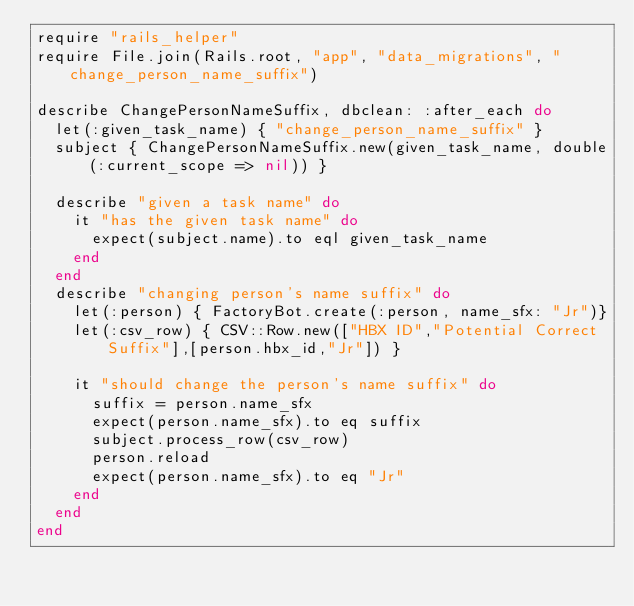<code> <loc_0><loc_0><loc_500><loc_500><_Ruby_>require "rails_helper"
require File.join(Rails.root, "app", "data_migrations", "change_person_name_suffix")

describe ChangePersonNameSuffix, dbclean: :after_each do
  let(:given_task_name) { "change_person_name_suffix" }
  subject { ChangePersonNameSuffix.new(given_task_name, double(:current_scope => nil)) }

  describe "given a task name" do
    it "has the given task name" do
      expect(subject.name).to eql given_task_name
    end
  end
  describe "changing person's name suffix" do
    let(:person) { FactoryBot.create(:person, name_sfx: "Jr")}
    let(:csv_row) { CSV::Row.new(["HBX ID","Potential Correct Suffix"],[person.hbx_id,"Jr"]) }

    it "should change the person's name suffix" do
      suffix = person.name_sfx
      expect(person.name_sfx).to eq suffix
      subject.process_row(csv_row)
      person.reload
      expect(person.name_sfx).to eq "Jr"
    end
  end
end
</code> 